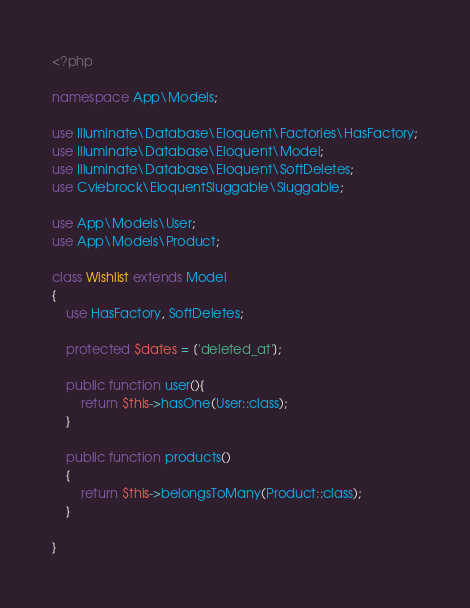Convert code to text. <code><loc_0><loc_0><loc_500><loc_500><_PHP_><?php

namespace App\Models;

use Illuminate\Database\Eloquent\Factories\HasFactory;
use Illuminate\Database\Eloquent\Model;
use Illuminate\Database\Eloquent\SoftDeletes;
use Cviebrock\EloquentSluggable\Sluggable;

use App\Models\User;
use App\Models\Product;

class Wishlist extends Model
{
    use HasFactory, SoftDeletes;

    protected $dates = ['deleted_at'];

    public function user(){
        return $this->hasOne(User::class);
    }

    public function products()
    {
        return $this->belongsToMany(Product::class);
    }
    
}
</code> 